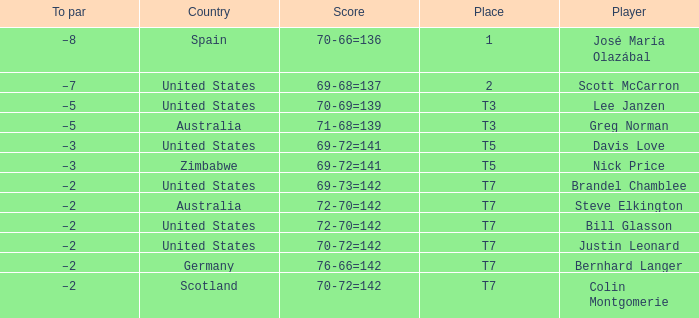Name the Player who has a Place of t7 in Country of united states? Brandel Chamblee, Bill Glasson, Justin Leonard. Could you parse the entire table? {'header': ['To par', 'Country', 'Score', 'Place', 'Player'], 'rows': [['–8', 'Spain', '70-66=136', '1', 'José María Olazábal'], ['–7', 'United States', '69-68=137', '2', 'Scott McCarron'], ['–5', 'United States', '70-69=139', 'T3', 'Lee Janzen'], ['–5', 'Australia', '71-68=139', 'T3', 'Greg Norman'], ['–3', 'United States', '69-72=141', 'T5', 'Davis Love'], ['–3', 'Zimbabwe', '69-72=141', 'T5', 'Nick Price'], ['–2', 'United States', '69-73=142', 'T7', 'Brandel Chamblee'], ['–2', 'Australia', '72-70=142', 'T7', 'Steve Elkington'], ['–2', 'United States', '72-70=142', 'T7', 'Bill Glasson'], ['–2', 'United States', '70-72=142', 'T7', 'Justin Leonard'], ['–2', 'Germany', '76-66=142', 'T7', 'Bernhard Langer'], ['–2', 'Scotland', '70-72=142', 'T7', 'Colin Montgomerie']]} 